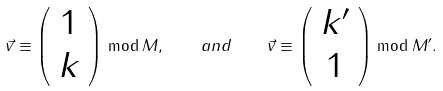Convert formula to latex. <formula><loc_0><loc_0><loc_500><loc_500>\vec { v } \equiv \left ( \begin{array} { c } 1 \\ k \end{array} \right ) \bmod M , \quad a n d \quad \vec { v } \equiv \left ( \begin{array} { c } k ^ { \prime } \\ 1 \end{array} \right ) \bmod M ^ { \prime } .</formula> 